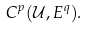<formula> <loc_0><loc_0><loc_500><loc_500>C ^ { p } ( { \mathcal { U } } , E ^ { q } ) .</formula> 